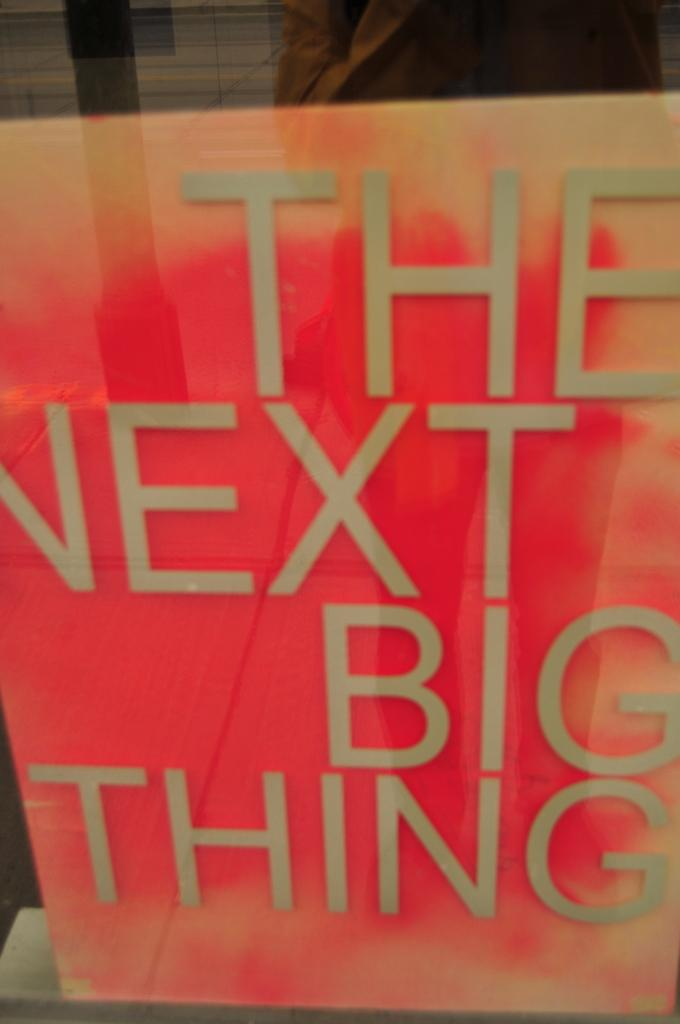<image>
Give a short and clear explanation of the subsequent image. Orange book with large text that reads " The Next Big Thing". 